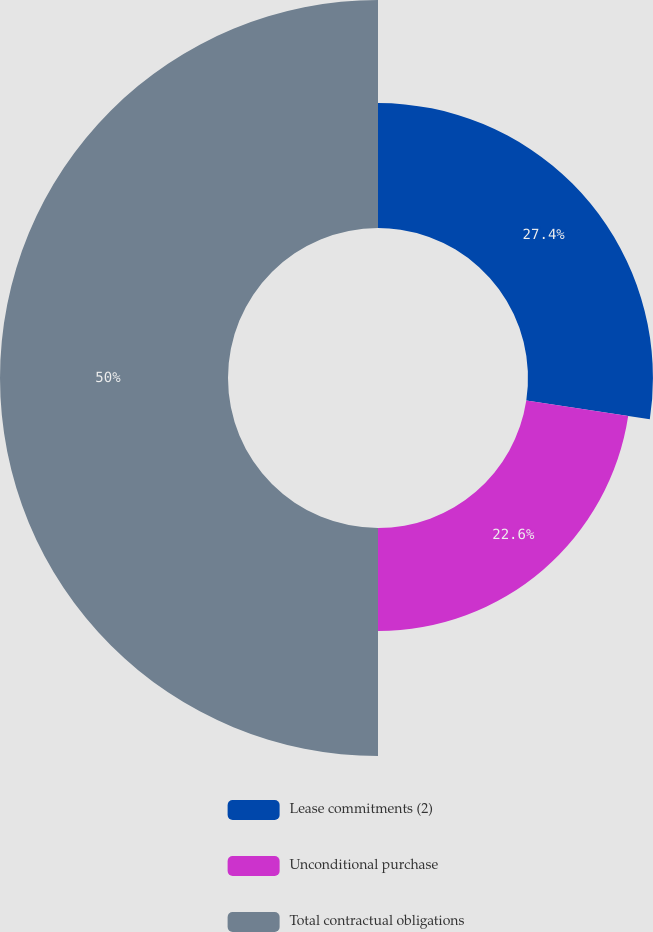<chart> <loc_0><loc_0><loc_500><loc_500><pie_chart><fcel>Lease commitments (2)<fcel>Unconditional purchase<fcel>Total contractual obligations<nl><fcel>27.4%<fcel>22.6%<fcel>50.0%<nl></chart> 